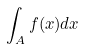Convert formula to latex. <formula><loc_0><loc_0><loc_500><loc_500>\int _ { A } f ( x ) d x</formula> 